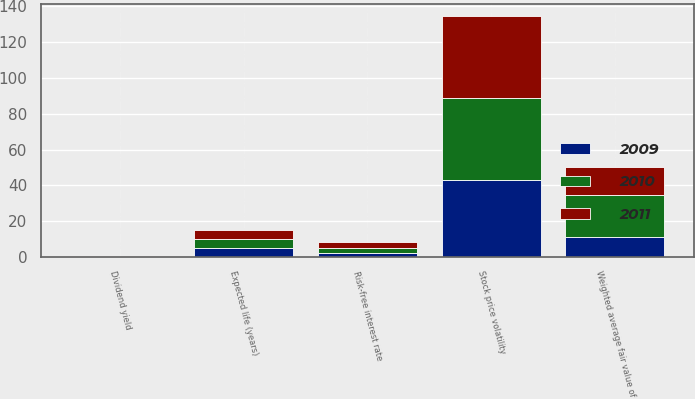<chart> <loc_0><loc_0><loc_500><loc_500><stacked_bar_chart><ecel><fcel>Dividend yield<fcel>Risk-free interest rate<fcel>Stock price volatility<fcel>Expected life (years)<fcel>Weighted average fair value of<nl><fcel>2010<fcel>0.08<fcel>3<fcel>45.6<fcel>5<fcel>23.2<nl><fcel>2011<fcel>0.1<fcel>3.2<fcel>46.1<fcel>5<fcel>15.69<nl><fcel>2009<fcel>0.13<fcel>2.1<fcel>43.1<fcel>5<fcel>11.3<nl></chart> 